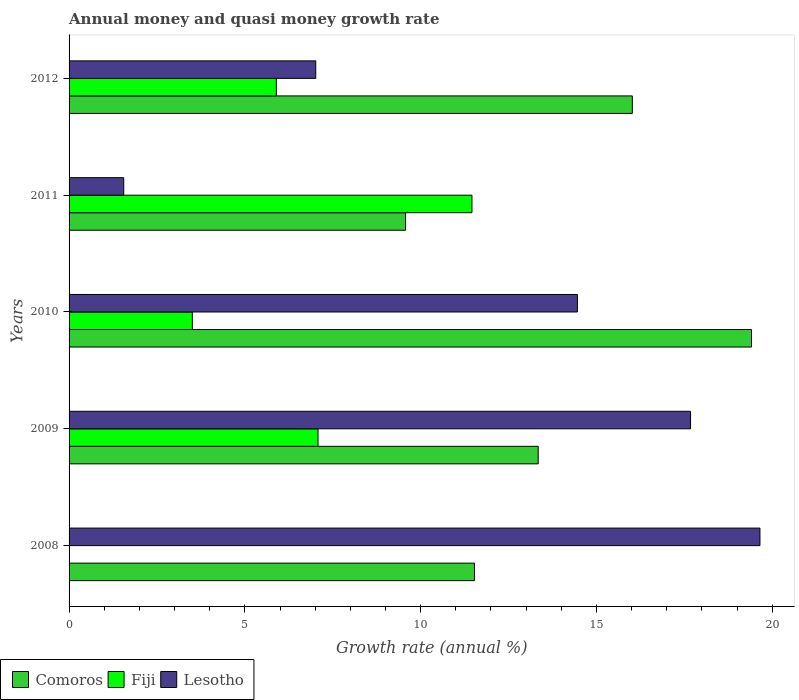How many groups of bars are there?
Give a very brief answer. 5. Are the number of bars per tick equal to the number of legend labels?
Provide a succinct answer. No. Are the number of bars on each tick of the Y-axis equal?
Your response must be concise. No. How many bars are there on the 5th tick from the top?
Provide a short and direct response. 2. What is the label of the 2nd group of bars from the top?
Ensure brevity in your answer.  2011. In how many cases, is the number of bars for a given year not equal to the number of legend labels?
Ensure brevity in your answer.  1. What is the growth rate in Comoros in 2009?
Provide a short and direct response. 13.34. Across all years, what is the maximum growth rate in Lesotho?
Make the answer very short. 19.65. Across all years, what is the minimum growth rate in Lesotho?
Keep it short and to the point. 1.55. In which year was the growth rate in Fiji maximum?
Your answer should be compact. 2011. What is the total growth rate in Comoros in the graph?
Provide a short and direct response. 69.88. What is the difference between the growth rate in Comoros in 2009 and that in 2011?
Ensure brevity in your answer.  3.77. What is the difference between the growth rate in Lesotho in 2011 and the growth rate in Fiji in 2012?
Your answer should be compact. -4.34. What is the average growth rate in Comoros per year?
Your response must be concise. 13.98. In the year 2011, what is the difference between the growth rate in Fiji and growth rate in Lesotho?
Ensure brevity in your answer.  9.91. In how many years, is the growth rate in Comoros greater than 8 %?
Make the answer very short. 5. What is the ratio of the growth rate in Comoros in 2009 to that in 2011?
Make the answer very short. 1.39. What is the difference between the highest and the second highest growth rate in Fiji?
Make the answer very short. 4.38. What is the difference between the highest and the lowest growth rate in Fiji?
Keep it short and to the point. 11.46. In how many years, is the growth rate in Lesotho greater than the average growth rate in Lesotho taken over all years?
Provide a succinct answer. 3. Is the sum of the growth rate in Lesotho in 2008 and 2011 greater than the maximum growth rate in Fiji across all years?
Your answer should be very brief. Yes. Is it the case that in every year, the sum of the growth rate in Lesotho and growth rate in Fiji is greater than the growth rate in Comoros?
Provide a short and direct response. No. How many bars are there?
Your response must be concise. 14. Are all the bars in the graph horizontal?
Give a very brief answer. Yes. Does the graph contain any zero values?
Ensure brevity in your answer.  Yes. Where does the legend appear in the graph?
Provide a succinct answer. Bottom left. What is the title of the graph?
Provide a succinct answer. Annual money and quasi money growth rate. Does "Malawi" appear as one of the legend labels in the graph?
Provide a succinct answer. No. What is the label or title of the X-axis?
Make the answer very short. Growth rate (annual %). What is the label or title of the Y-axis?
Ensure brevity in your answer.  Years. What is the Growth rate (annual %) of Comoros in 2008?
Keep it short and to the point. 11.53. What is the Growth rate (annual %) in Fiji in 2008?
Provide a short and direct response. 0. What is the Growth rate (annual %) in Lesotho in 2008?
Give a very brief answer. 19.65. What is the Growth rate (annual %) of Comoros in 2009?
Your response must be concise. 13.34. What is the Growth rate (annual %) in Fiji in 2009?
Ensure brevity in your answer.  7.08. What is the Growth rate (annual %) in Lesotho in 2009?
Keep it short and to the point. 17.68. What is the Growth rate (annual %) in Comoros in 2010?
Keep it short and to the point. 19.41. What is the Growth rate (annual %) of Fiji in 2010?
Ensure brevity in your answer.  3.51. What is the Growth rate (annual %) of Lesotho in 2010?
Provide a succinct answer. 14.46. What is the Growth rate (annual %) in Comoros in 2011?
Your answer should be compact. 9.57. What is the Growth rate (annual %) in Fiji in 2011?
Provide a succinct answer. 11.46. What is the Growth rate (annual %) of Lesotho in 2011?
Give a very brief answer. 1.55. What is the Growth rate (annual %) of Comoros in 2012?
Offer a very short reply. 16.02. What is the Growth rate (annual %) of Fiji in 2012?
Keep it short and to the point. 5.9. What is the Growth rate (annual %) in Lesotho in 2012?
Ensure brevity in your answer.  7.02. Across all years, what is the maximum Growth rate (annual %) of Comoros?
Offer a very short reply. 19.41. Across all years, what is the maximum Growth rate (annual %) in Fiji?
Offer a terse response. 11.46. Across all years, what is the maximum Growth rate (annual %) of Lesotho?
Provide a succinct answer. 19.65. Across all years, what is the minimum Growth rate (annual %) of Comoros?
Offer a very short reply. 9.57. Across all years, what is the minimum Growth rate (annual %) in Lesotho?
Your answer should be very brief. 1.55. What is the total Growth rate (annual %) in Comoros in the graph?
Give a very brief answer. 69.88. What is the total Growth rate (annual %) in Fiji in the graph?
Make the answer very short. 27.94. What is the total Growth rate (annual %) of Lesotho in the graph?
Give a very brief answer. 60.36. What is the difference between the Growth rate (annual %) in Comoros in 2008 and that in 2009?
Keep it short and to the point. -1.81. What is the difference between the Growth rate (annual %) of Lesotho in 2008 and that in 2009?
Provide a short and direct response. 1.97. What is the difference between the Growth rate (annual %) in Comoros in 2008 and that in 2010?
Give a very brief answer. -7.88. What is the difference between the Growth rate (annual %) in Lesotho in 2008 and that in 2010?
Your answer should be compact. 5.19. What is the difference between the Growth rate (annual %) in Comoros in 2008 and that in 2011?
Offer a terse response. 1.96. What is the difference between the Growth rate (annual %) of Lesotho in 2008 and that in 2011?
Your response must be concise. 18.1. What is the difference between the Growth rate (annual %) in Comoros in 2008 and that in 2012?
Offer a very short reply. -4.49. What is the difference between the Growth rate (annual %) in Lesotho in 2008 and that in 2012?
Keep it short and to the point. 12.64. What is the difference between the Growth rate (annual %) of Comoros in 2009 and that in 2010?
Your answer should be very brief. -6.07. What is the difference between the Growth rate (annual %) of Fiji in 2009 and that in 2010?
Provide a short and direct response. 3.58. What is the difference between the Growth rate (annual %) in Lesotho in 2009 and that in 2010?
Provide a succinct answer. 3.22. What is the difference between the Growth rate (annual %) of Comoros in 2009 and that in 2011?
Your response must be concise. 3.77. What is the difference between the Growth rate (annual %) in Fiji in 2009 and that in 2011?
Your answer should be compact. -4.38. What is the difference between the Growth rate (annual %) in Lesotho in 2009 and that in 2011?
Your answer should be very brief. 16.12. What is the difference between the Growth rate (annual %) in Comoros in 2009 and that in 2012?
Provide a short and direct response. -2.68. What is the difference between the Growth rate (annual %) of Fiji in 2009 and that in 2012?
Ensure brevity in your answer.  1.19. What is the difference between the Growth rate (annual %) in Lesotho in 2009 and that in 2012?
Provide a succinct answer. 10.66. What is the difference between the Growth rate (annual %) in Comoros in 2010 and that in 2011?
Offer a very short reply. 9.84. What is the difference between the Growth rate (annual %) in Fiji in 2010 and that in 2011?
Ensure brevity in your answer.  -7.95. What is the difference between the Growth rate (annual %) of Lesotho in 2010 and that in 2011?
Offer a terse response. 12.9. What is the difference between the Growth rate (annual %) in Comoros in 2010 and that in 2012?
Your answer should be compact. 3.39. What is the difference between the Growth rate (annual %) of Fiji in 2010 and that in 2012?
Provide a short and direct response. -2.39. What is the difference between the Growth rate (annual %) in Lesotho in 2010 and that in 2012?
Give a very brief answer. 7.44. What is the difference between the Growth rate (annual %) of Comoros in 2011 and that in 2012?
Make the answer very short. -6.45. What is the difference between the Growth rate (annual %) of Fiji in 2011 and that in 2012?
Offer a terse response. 5.56. What is the difference between the Growth rate (annual %) in Lesotho in 2011 and that in 2012?
Ensure brevity in your answer.  -5.46. What is the difference between the Growth rate (annual %) of Comoros in 2008 and the Growth rate (annual %) of Fiji in 2009?
Ensure brevity in your answer.  4.45. What is the difference between the Growth rate (annual %) of Comoros in 2008 and the Growth rate (annual %) of Lesotho in 2009?
Give a very brief answer. -6.15. What is the difference between the Growth rate (annual %) of Comoros in 2008 and the Growth rate (annual %) of Fiji in 2010?
Offer a terse response. 8.03. What is the difference between the Growth rate (annual %) of Comoros in 2008 and the Growth rate (annual %) of Lesotho in 2010?
Make the answer very short. -2.93. What is the difference between the Growth rate (annual %) of Comoros in 2008 and the Growth rate (annual %) of Fiji in 2011?
Offer a very short reply. 0.07. What is the difference between the Growth rate (annual %) in Comoros in 2008 and the Growth rate (annual %) in Lesotho in 2011?
Provide a succinct answer. 9.98. What is the difference between the Growth rate (annual %) of Comoros in 2008 and the Growth rate (annual %) of Fiji in 2012?
Keep it short and to the point. 5.64. What is the difference between the Growth rate (annual %) in Comoros in 2008 and the Growth rate (annual %) in Lesotho in 2012?
Make the answer very short. 4.52. What is the difference between the Growth rate (annual %) in Comoros in 2009 and the Growth rate (annual %) in Fiji in 2010?
Offer a very short reply. 9.84. What is the difference between the Growth rate (annual %) of Comoros in 2009 and the Growth rate (annual %) of Lesotho in 2010?
Your answer should be compact. -1.11. What is the difference between the Growth rate (annual %) in Fiji in 2009 and the Growth rate (annual %) in Lesotho in 2010?
Give a very brief answer. -7.38. What is the difference between the Growth rate (annual %) of Comoros in 2009 and the Growth rate (annual %) of Fiji in 2011?
Your response must be concise. 1.88. What is the difference between the Growth rate (annual %) of Comoros in 2009 and the Growth rate (annual %) of Lesotho in 2011?
Provide a succinct answer. 11.79. What is the difference between the Growth rate (annual %) in Fiji in 2009 and the Growth rate (annual %) in Lesotho in 2011?
Your response must be concise. 5.53. What is the difference between the Growth rate (annual %) in Comoros in 2009 and the Growth rate (annual %) in Fiji in 2012?
Make the answer very short. 7.45. What is the difference between the Growth rate (annual %) in Comoros in 2009 and the Growth rate (annual %) in Lesotho in 2012?
Offer a very short reply. 6.33. What is the difference between the Growth rate (annual %) of Fiji in 2009 and the Growth rate (annual %) of Lesotho in 2012?
Give a very brief answer. 0.07. What is the difference between the Growth rate (annual %) in Comoros in 2010 and the Growth rate (annual %) in Fiji in 2011?
Offer a terse response. 7.95. What is the difference between the Growth rate (annual %) of Comoros in 2010 and the Growth rate (annual %) of Lesotho in 2011?
Keep it short and to the point. 17.86. What is the difference between the Growth rate (annual %) in Fiji in 2010 and the Growth rate (annual %) in Lesotho in 2011?
Your response must be concise. 1.95. What is the difference between the Growth rate (annual %) of Comoros in 2010 and the Growth rate (annual %) of Fiji in 2012?
Offer a very short reply. 13.52. What is the difference between the Growth rate (annual %) in Comoros in 2010 and the Growth rate (annual %) in Lesotho in 2012?
Give a very brief answer. 12.4. What is the difference between the Growth rate (annual %) of Fiji in 2010 and the Growth rate (annual %) of Lesotho in 2012?
Offer a terse response. -3.51. What is the difference between the Growth rate (annual %) of Comoros in 2011 and the Growth rate (annual %) of Fiji in 2012?
Your response must be concise. 3.68. What is the difference between the Growth rate (annual %) in Comoros in 2011 and the Growth rate (annual %) in Lesotho in 2012?
Make the answer very short. 2.56. What is the difference between the Growth rate (annual %) in Fiji in 2011 and the Growth rate (annual %) in Lesotho in 2012?
Your response must be concise. 4.44. What is the average Growth rate (annual %) in Comoros per year?
Ensure brevity in your answer.  13.98. What is the average Growth rate (annual %) of Fiji per year?
Offer a very short reply. 5.59. What is the average Growth rate (annual %) in Lesotho per year?
Offer a terse response. 12.07. In the year 2008, what is the difference between the Growth rate (annual %) in Comoros and Growth rate (annual %) in Lesotho?
Your answer should be very brief. -8.12. In the year 2009, what is the difference between the Growth rate (annual %) of Comoros and Growth rate (annual %) of Fiji?
Your answer should be compact. 6.26. In the year 2009, what is the difference between the Growth rate (annual %) of Comoros and Growth rate (annual %) of Lesotho?
Ensure brevity in your answer.  -4.33. In the year 2009, what is the difference between the Growth rate (annual %) in Fiji and Growth rate (annual %) in Lesotho?
Provide a succinct answer. -10.6. In the year 2010, what is the difference between the Growth rate (annual %) of Comoros and Growth rate (annual %) of Fiji?
Give a very brief answer. 15.91. In the year 2010, what is the difference between the Growth rate (annual %) of Comoros and Growth rate (annual %) of Lesotho?
Give a very brief answer. 4.95. In the year 2010, what is the difference between the Growth rate (annual %) of Fiji and Growth rate (annual %) of Lesotho?
Offer a very short reply. -10.95. In the year 2011, what is the difference between the Growth rate (annual %) of Comoros and Growth rate (annual %) of Fiji?
Give a very brief answer. -1.89. In the year 2011, what is the difference between the Growth rate (annual %) in Comoros and Growth rate (annual %) in Lesotho?
Your answer should be very brief. 8.02. In the year 2011, what is the difference between the Growth rate (annual %) of Fiji and Growth rate (annual %) of Lesotho?
Give a very brief answer. 9.91. In the year 2012, what is the difference between the Growth rate (annual %) in Comoros and Growth rate (annual %) in Fiji?
Ensure brevity in your answer.  10.13. In the year 2012, what is the difference between the Growth rate (annual %) of Comoros and Growth rate (annual %) of Lesotho?
Your answer should be compact. 9.01. In the year 2012, what is the difference between the Growth rate (annual %) in Fiji and Growth rate (annual %) in Lesotho?
Give a very brief answer. -1.12. What is the ratio of the Growth rate (annual %) of Comoros in 2008 to that in 2009?
Keep it short and to the point. 0.86. What is the ratio of the Growth rate (annual %) in Lesotho in 2008 to that in 2009?
Your response must be concise. 1.11. What is the ratio of the Growth rate (annual %) in Comoros in 2008 to that in 2010?
Make the answer very short. 0.59. What is the ratio of the Growth rate (annual %) in Lesotho in 2008 to that in 2010?
Ensure brevity in your answer.  1.36. What is the ratio of the Growth rate (annual %) in Comoros in 2008 to that in 2011?
Provide a succinct answer. 1.2. What is the ratio of the Growth rate (annual %) in Lesotho in 2008 to that in 2011?
Offer a terse response. 12.64. What is the ratio of the Growth rate (annual %) of Comoros in 2008 to that in 2012?
Offer a very short reply. 0.72. What is the ratio of the Growth rate (annual %) in Lesotho in 2008 to that in 2012?
Provide a succinct answer. 2.8. What is the ratio of the Growth rate (annual %) of Comoros in 2009 to that in 2010?
Your response must be concise. 0.69. What is the ratio of the Growth rate (annual %) of Fiji in 2009 to that in 2010?
Provide a succinct answer. 2.02. What is the ratio of the Growth rate (annual %) in Lesotho in 2009 to that in 2010?
Offer a terse response. 1.22. What is the ratio of the Growth rate (annual %) of Comoros in 2009 to that in 2011?
Ensure brevity in your answer.  1.39. What is the ratio of the Growth rate (annual %) of Fiji in 2009 to that in 2011?
Your answer should be very brief. 0.62. What is the ratio of the Growth rate (annual %) of Lesotho in 2009 to that in 2011?
Offer a very short reply. 11.37. What is the ratio of the Growth rate (annual %) of Comoros in 2009 to that in 2012?
Ensure brevity in your answer.  0.83. What is the ratio of the Growth rate (annual %) in Fiji in 2009 to that in 2012?
Offer a terse response. 1.2. What is the ratio of the Growth rate (annual %) in Lesotho in 2009 to that in 2012?
Offer a very short reply. 2.52. What is the ratio of the Growth rate (annual %) in Comoros in 2010 to that in 2011?
Ensure brevity in your answer.  2.03. What is the ratio of the Growth rate (annual %) in Fiji in 2010 to that in 2011?
Provide a succinct answer. 0.31. What is the ratio of the Growth rate (annual %) in Lesotho in 2010 to that in 2011?
Provide a succinct answer. 9.3. What is the ratio of the Growth rate (annual %) of Comoros in 2010 to that in 2012?
Your answer should be very brief. 1.21. What is the ratio of the Growth rate (annual %) in Fiji in 2010 to that in 2012?
Give a very brief answer. 0.59. What is the ratio of the Growth rate (annual %) of Lesotho in 2010 to that in 2012?
Give a very brief answer. 2.06. What is the ratio of the Growth rate (annual %) of Comoros in 2011 to that in 2012?
Provide a short and direct response. 0.6. What is the ratio of the Growth rate (annual %) of Fiji in 2011 to that in 2012?
Keep it short and to the point. 1.94. What is the ratio of the Growth rate (annual %) in Lesotho in 2011 to that in 2012?
Provide a short and direct response. 0.22. What is the difference between the highest and the second highest Growth rate (annual %) in Comoros?
Provide a succinct answer. 3.39. What is the difference between the highest and the second highest Growth rate (annual %) of Fiji?
Provide a short and direct response. 4.38. What is the difference between the highest and the second highest Growth rate (annual %) of Lesotho?
Ensure brevity in your answer.  1.97. What is the difference between the highest and the lowest Growth rate (annual %) in Comoros?
Provide a short and direct response. 9.84. What is the difference between the highest and the lowest Growth rate (annual %) in Fiji?
Ensure brevity in your answer.  11.46. What is the difference between the highest and the lowest Growth rate (annual %) in Lesotho?
Offer a terse response. 18.1. 